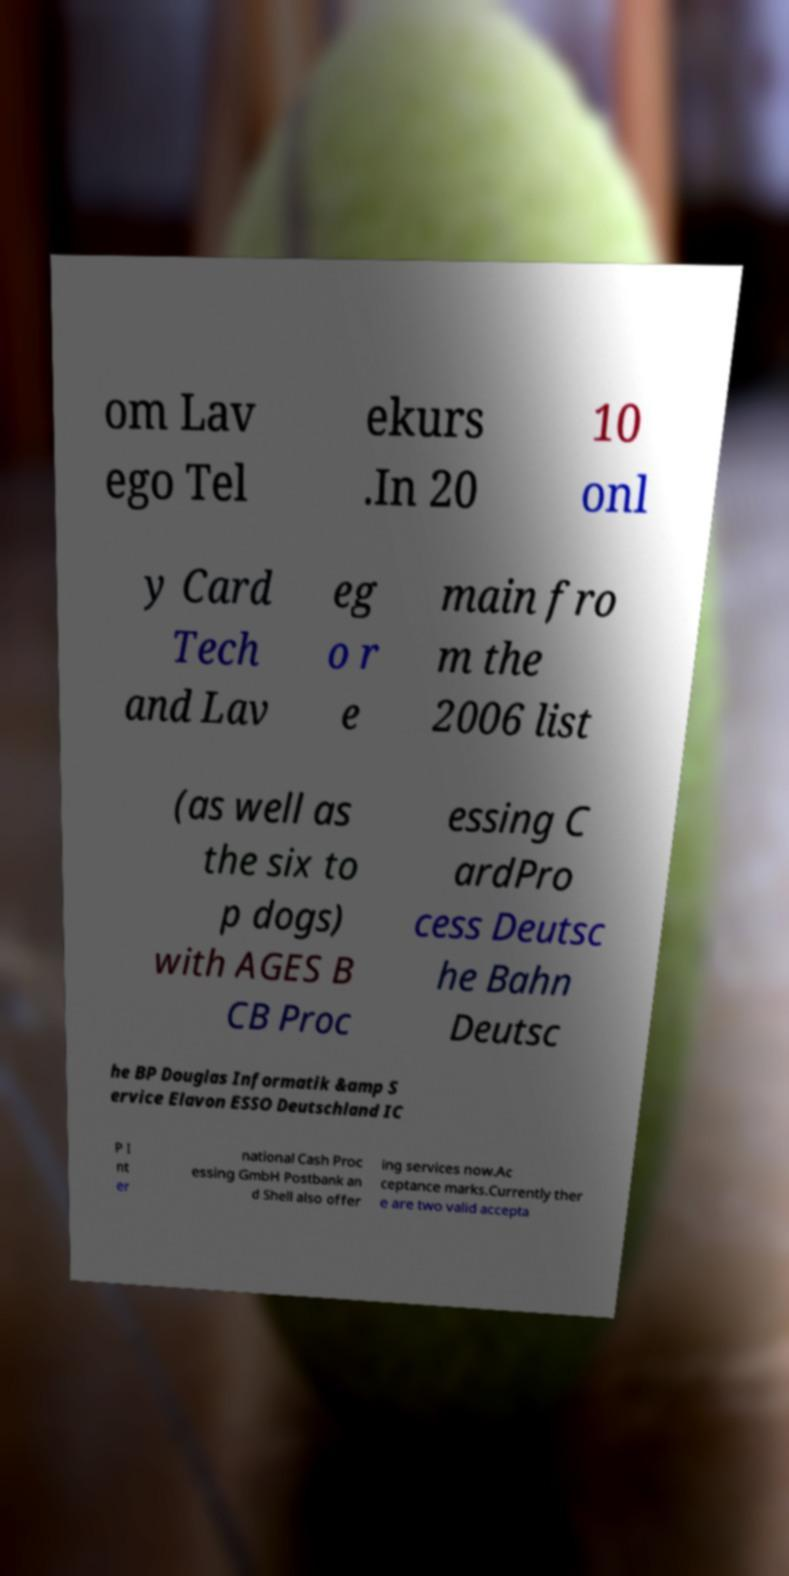Please read and relay the text visible in this image. What does it say? om Lav ego Tel ekurs .In 20 10 onl y Card Tech and Lav eg o r e main fro m the 2006 list (as well as the six to p dogs) with AGES B CB Proc essing C ardPro cess Deutsc he Bahn Deutsc he BP Douglas Informatik &amp S ervice Elavon ESSO Deutschland IC P I nt er national Cash Proc essing GmbH Postbank an d Shell also offer ing services now.Ac ceptance marks.Currently ther e are two valid accepta 